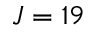Convert formula to latex. <formula><loc_0><loc_0><loc_500><loc_500>J = 1 9</formula> 